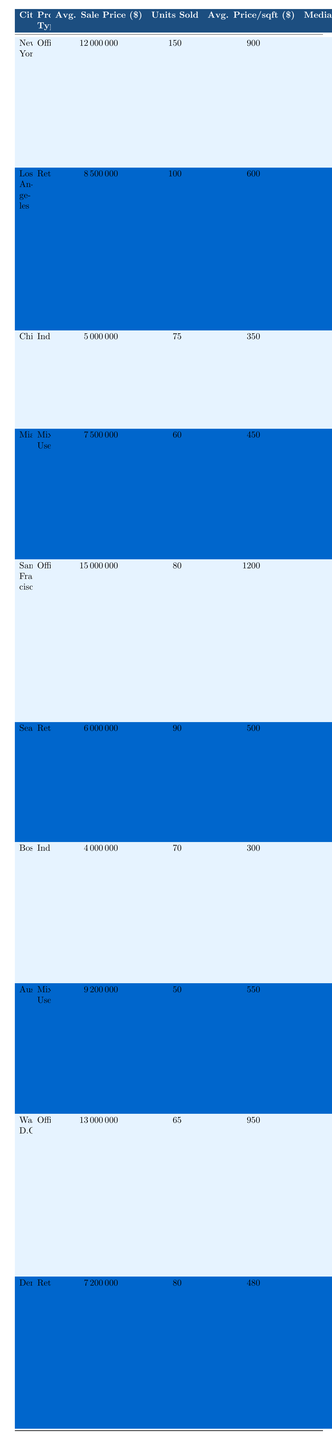What is the average sale price of properties in New York? The table indicates that the average sale price of properties in New York is 12,000,000 dollars.
Answer: 12,000,000 How many total units were sold in Seattle for retail properties? Referring to the table, the total units sold for retail properties in Seattle is 90.
Answer: 90 What is the median sale price of mixed-use properties in Miami? From the table, the median sale price of mixed-use properties in Miami is 7,400,000 dollars.
Answer: 7,400,000 Which city had the highest average sale price for office properties? In the table, San Francisco has the highest average sale price for office properties at 15,000,000 dollars.
Answer: San Francisco What is the total number of units sold for all office properties combined? Adding the units sold: New York (150) + San Francisco (80) + Washington, D.C. (65) gives a total of 295 units sold.
Answer: 295 What is the average price per square foot for retail properties in Los Angeles? The table shows that the average price per square foot for retail properties in Los Angeles is 600 dollars.
Answer: 600 Is the market trend for commercial properties in Chicago indicating growth or decline? The market trend for Chicago indicates steady growth driven by e-commerce logistics, which signifies growth.
Answer: Growth Which city had the lowest average sale price for industrial properties and what was it? The table shows Boston had the lowest average sale price for industrial properties at 4,000,000 dollars.
Answer: 4,000,000 What is the difference between the average sale prices of office properties in New York and Washington, D.C.? The average sale price in New York is 12,000,000 and in Washington, D.C. is 13,000,000. The difference is 13,000,000 - 12,000,000 = 1,000,000 dollars.
Answer: 1,000,000 In which city is there a noted increase in warehouse space demand? The table states that in Boston, there is an increase in warehouse space demand, particularly for storage.
Answer: Boston How many square feet were sold for mixed-use properties in Austin? The table indicates that 800,000 square feet were sold for mixed-use properties in Austin.
Answer: 800,000 